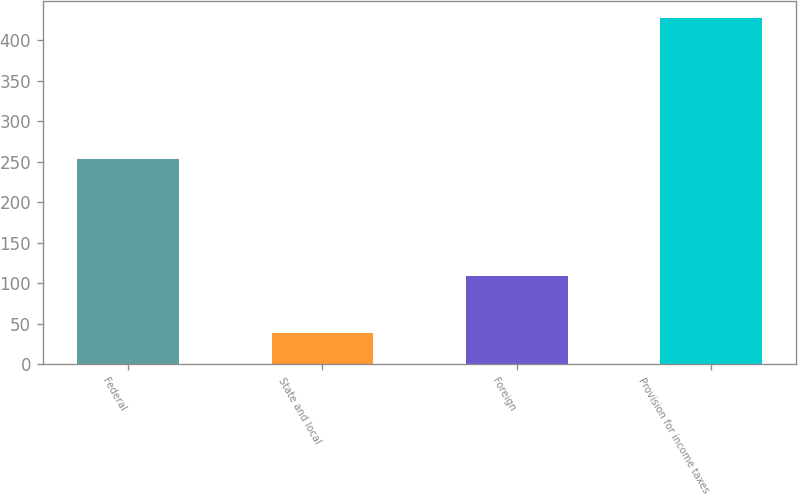<chart> <loc_0><loc_0><loc_500><loc_500><bar_chart><fcel>Federal<fcel>State and local<fcel>Foreign<fcel>Provision for income taxes<nl><fcel>253<fcel>38<fcel>109<fcel>427<nl></chart> 